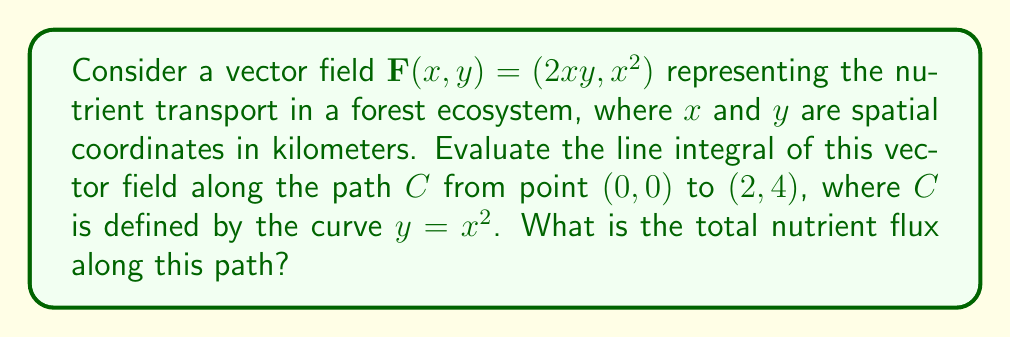Show me your answer to this math problem. To evaluate the line integral, we'll follow these steps:

1) The vector field is $\mathbf{F}(x,y) = (2xy, x^2)$

2) The path $C$ is defined by $y = x^2$ from $(0,0)$ to $(2,4)$

3) We need to parameterize the curve. Let $x = t$, then $y = t^2$, where $0 \leq t \leq 2$

4) The parametric equations are:
   $x(t) = t$
   $y(t) = t^2$

5) Calculate $\frac{dx}{dt}$ and $\frac{dy}{dt}$:
   $\frac{dx}{dt} = 1$
   $\frac{dy}{dt} = 2t$

6) The line integral formula is:
   $$\int_C \mathbf{F} \cdot d\mathbf{r} = \int_a^b \mathbf{F}(x(t),y(t)) \cdot (\frac{dx}{dt}, \frac{dy}{dt}) dt$$

7) Substituting our values:
   $$\int_0^2 (2t(t^2), t^2) \cdot (1, 2t) dt$$

8) Simplifying:
   $$\int_0^2 (2t^3 + 2t^3) dt = \int_0^2 4t^3 dt$$

9) Integrating:
   $$[t^4]_0^2 = 2^4 - 0^4 = 16$$

Therefore, the total nutrient flux along the path is 16 nutrient units.
Answer: 16 nutrient units 